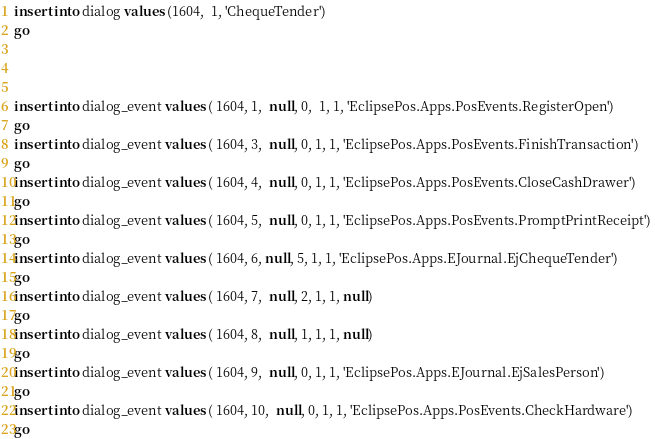<code> <loc_0><loc_0><loc_500><loc_500><_SQL_>


insert into dialog values (1604,  1, 'ChequeTender') 
go



insert into dialog_event values ( 1604, 1,  null, 0,  1, 1, 'EclipsePos.Apps.PosEvents.RegisterOpen') 
go
insert into dialog_event values ( 1604, 3,  null, 0, 1, 1, 'EclipsePos.Apps.PosEvents.FinishTransaction') 
go
insert into dialog_event values ( 1604, 4,  null, 0, 1, 1, 'EclipsePos.Apps.PosEvents.CloseCashDrawer') 
go
insert into dialog_event values ( 1604, 5,  null, 0, 1, 1, 'EclipsePos.Apps.PosEvents.PromptPrintReceipt') 
go
insert into dialog_event values ( 1604, 6, null, 5, 1, 1, 'EclipsePos.Apps.EJournal.EjChequeTender')  
go
insert into dialog_event values ( 1604, 7,  null, 2, 1, 1, null) 
go
insert into dialog_event values ( 1604, 8,  null, 1, 1, 1, null) 
go
insert into dialog_event values ( 1604, 9,  null, 0, 1, 1, 'EclipsePos.Apps.EJournal.EjSalesPerson') 
go
insert into dialog_event values ( 1604, 10,  null, 0, 1, 1, 'EclipsePos.Apps.PosEvents.CheckHardware') 
go</code> 